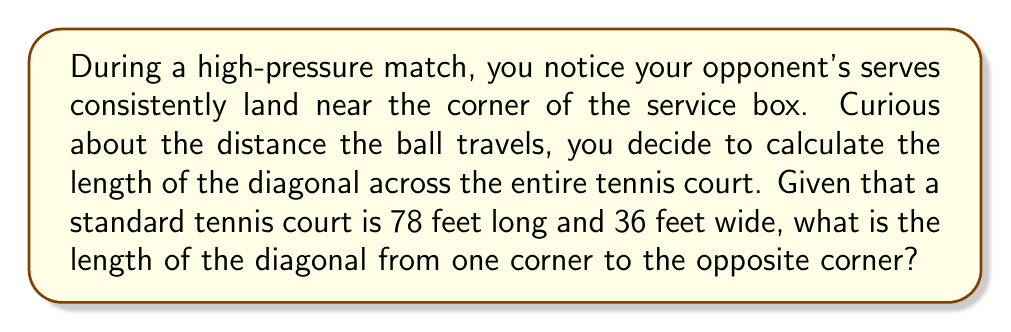Teach me how to tackle this problem. Let's approach this step-by-step using the Pythagorean theorem:

1) The tennis court forms a rectangle. The diagonal of a rectangle forms the hypotenuse of a right triangle.

2) Let's denote:
   $l$ = length of the court = 78 feet
   $w$ = width of the court = 36 feet
   $d$ = diagonal of the court (what we're solving for)

3) According to the Pythagorean theorem:
   $d^2 = l^2 + w^2$

4) Substituting the known values:
   $d^2 = 78^2 + 36^2$

5) Calculate the squares:
   $d^2 = 6084 + 1296 = 7380$

6) Take the square root of both sides:
   $d = \sqrt{7380}$

7) Simplify:
   $d = 2\sqrt{1845} \approx 85.87$ feet

[asy]
unitsize(2mm);
draw((0,0)--(78,0)--(78,36)--(0,36)--cycle);
draw((0,0)--(78,36),red);
label("78'",(39,0),S);
label("36'",(78,18),E);
label("d",(39,18),NW,red);
[/asy]
Answer: $2\sqrt{1845}$ feet or approximately 85.87 feet 